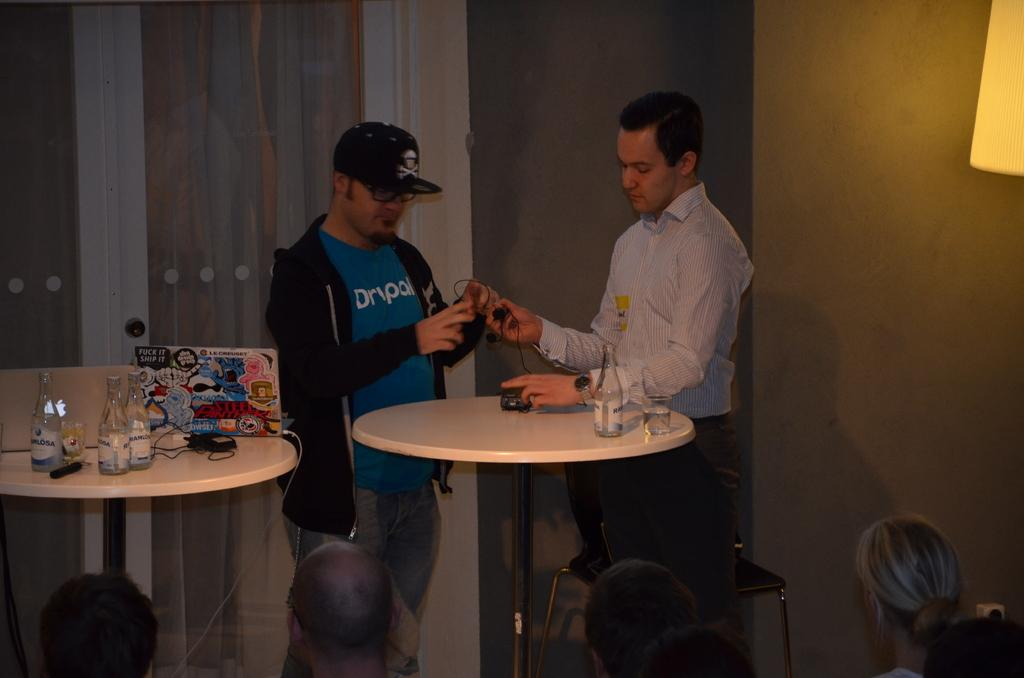How many people are in the image? There are two persons in the image. What are the persons doing in the image? The persons are standing at a table. What objects can be seen on the table? There is a wine bottle and a wine glass on the table. What is the position of one of the persons in the image? One of the persons is looking at the table. What channel is the person watching on the television in the image? There is no television present in the image, so it is not possible to determine what channel the person might be watching. 